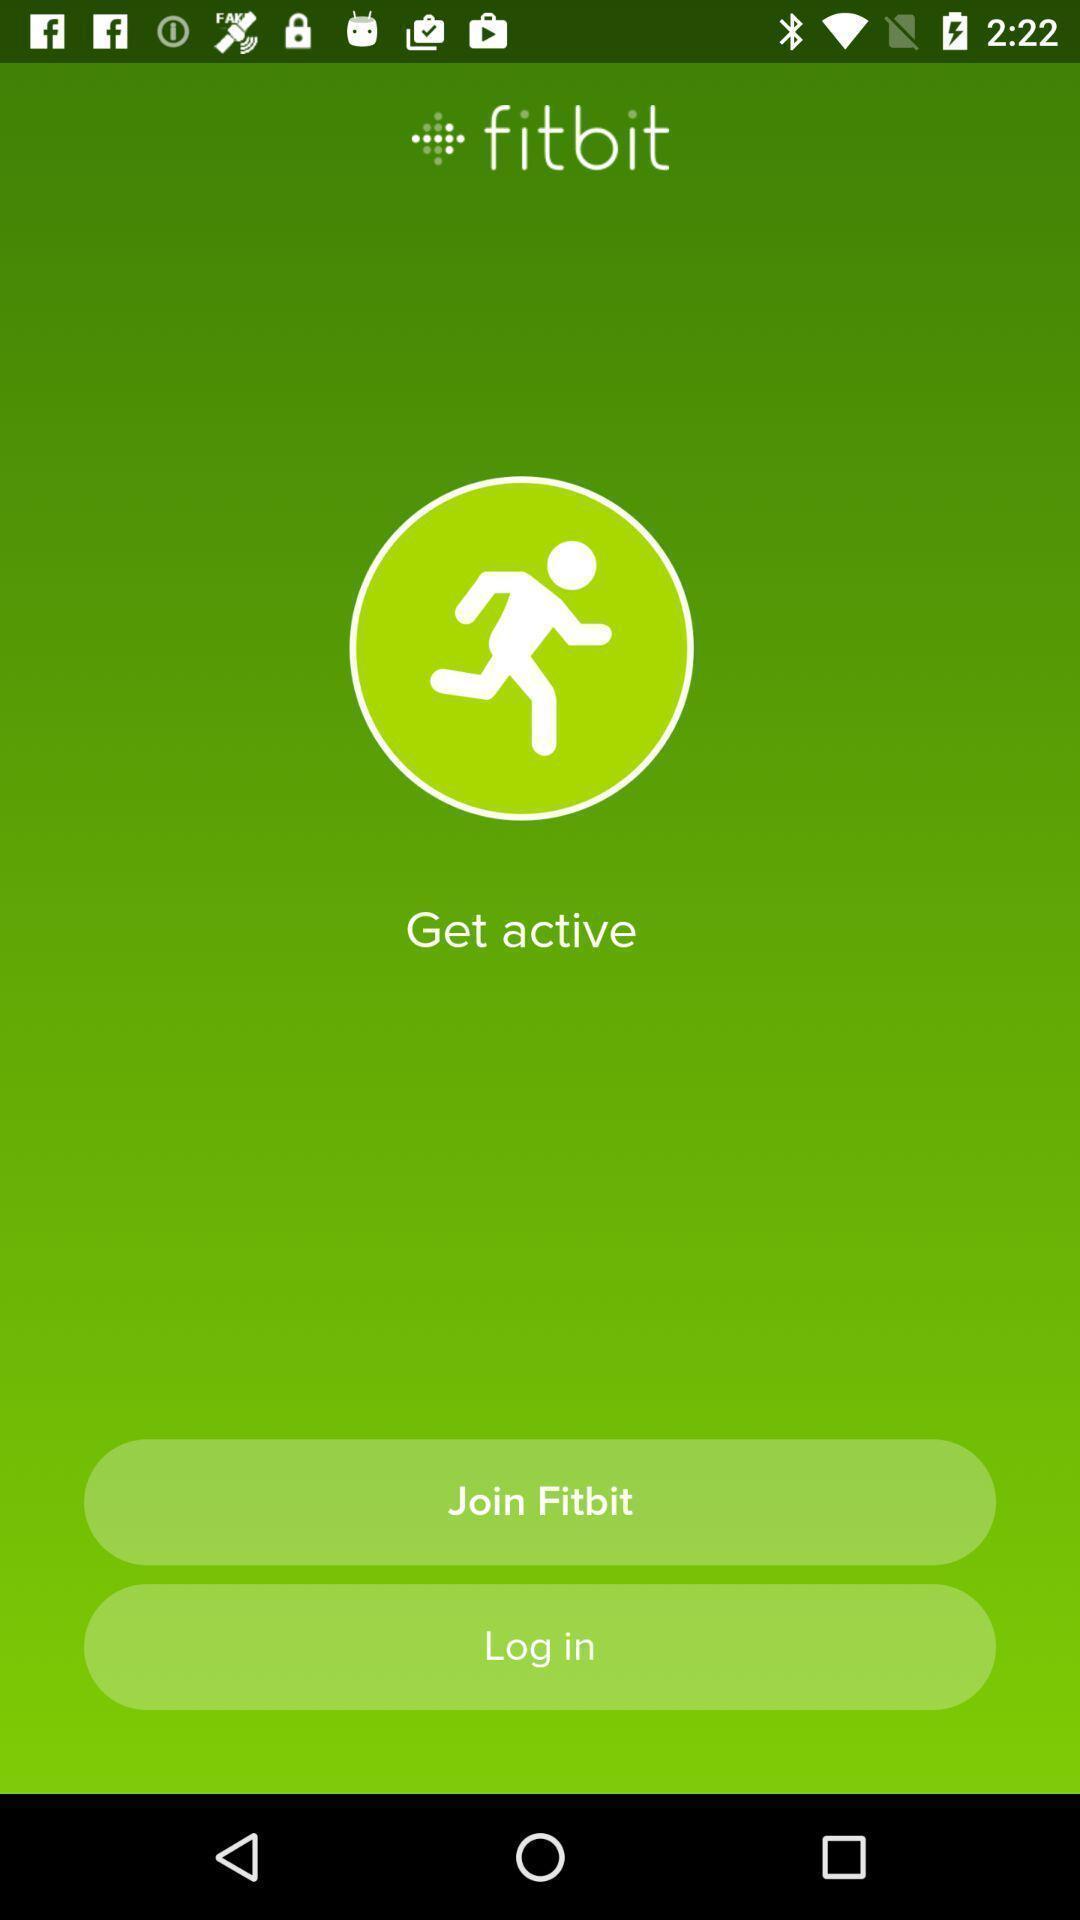What details can you identify in this image? Welcome page for a fitness tracker app. 